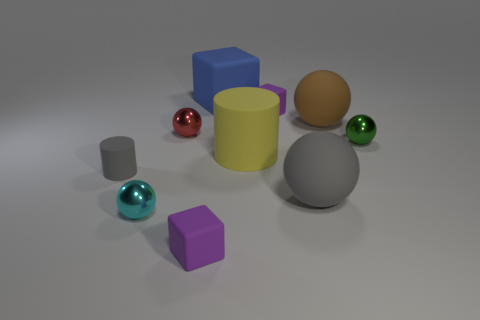How many other objects are there of the same material as the yellow thing?
Ensure brevity in your answer.  6. There is a purple cube that is right of the purple cube that is left of the big yellow rubber thing; are there any small purple matte cubes behind it?
Your answer should be compact. No. Does the small cylinder have the same material as the big cylinder?
Provide a short and direct response. Yes. Are there any other things that have the same shape as the large blue matte thing?
Give a very brief answer. Yes. There is a small purple object that is behind the large rubber sphere that is behind the gray matte sphere; what is its material?
Ensure brevity in your answer.  Rubber. What is the size of the purple thing in front of the large brown ball?
Offer a terse response. Small. The matte thing that is both left of the yellow object and behind the tiny red metallic sphere is what color?
Make the answer very short. Blue. Do the purple thing behind the yellow object and the big yellow matte cylinder have the same size?
Your answer should be compact. No. Is there a brown matte sphere that is in front of the tiny block that is in front of the small red shiny sphere?
Offer a terse response. No. What is the material of the red sphere?
Ensure brevity in your answer.  Metal. 